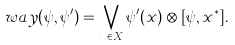Convert formula to latex. <formula><loc_0><loc_0><loc_500><loc_500>\ w a y ( \psi , \psi ^ { \prime } ) = \bigvee _ { x \in X } \psi ^ { \prime } ( x ) \otimes [ \psi , x ^ { * } ] .</formula> 